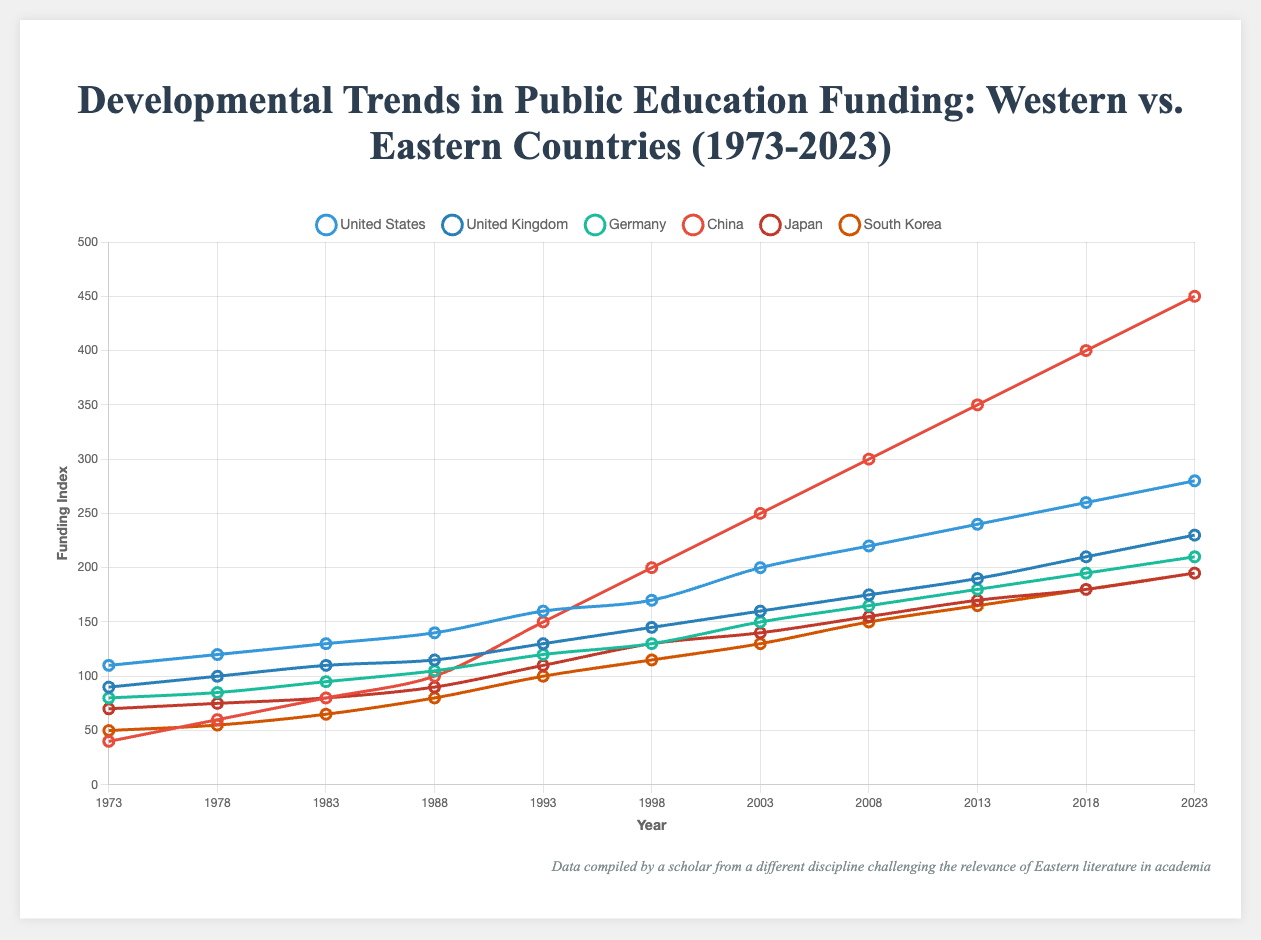Which country has the highest public education funding in the most recent year? Based on the data provided for 2023, observe the ending points of the lines representing each country's funding. The highest ending point corresponds to the highest funding.
Answer: China How does the educational funding trend for the United States compare to that of South Korea from 1973 to 2023? Examine the slope and relative position of the lines for the United States and South Korea over the years. The United States shows a steady increase, while South Korea, initially lower, shows a significant upward trend but does not surpass the United States.
Answer: United States has a steady increase, South Korea shows significant upward trend but remains lower What is the average annual increase in funding for Germany over the last 50 years? To calculate the average annual increase, take the difference between the funding in 2023 and 1973 for Germany, then divide by the number of years (50). (210 - 80) / 50 = 130 / 50
Answer: 2.6 Compare the funding trend for Japan and the United Kingdom. Which shows a higher growth rate? By observing the slopes of the lines for Japan and the United Kingdom, compare the steepness. Japan's line is less steep compared to the United Kingdom's, indicating a lower growth rate.
Answer: United Kingdom Which country showed the most significant increase in funding between 1983 and 1988? Identify the segment between 1983 and 1988 for all countries' lines. Compare the vertical distances (gains) between these points. China shows the most significant increase.
Answer: China What was the difference in funding between China and Japan in 1993? Locate the points for China and Japan in 1993, then calculate the difference in their fundings. 150 (China) - 110 (Japan) = 40
Answer: 40 Which Eastern country had the lowest funding in 2008? Compare the points in 2008 for the Eastern countries (China, Japan, and South Korea). Identify the lowest point.
Answer: South Korea Calculate the sum of educational funding for the United States, United Kingdom, and Germany in 2023. Sum the funding values for the United States (280), United Kingdom (230), and Germany (210) in 2023. 280 + 230 + 210 = 720
Answer: 720 Which Western country had the greatest increase in funding from 1978 to 1983? Examine the segment from 1978 to 1983 for Western countries' lines. The one with the steepest increase is the greatest. The United States shows the most significant increase from 120 to 130.
Answer: United States Identify the country with a red-colored line and describe its funding trend. The red-colored line represents China. Observing this line shows a steep and consistent upward trend, reflecting substantial growth in funding.
Answer: China, steep and consistent increase 